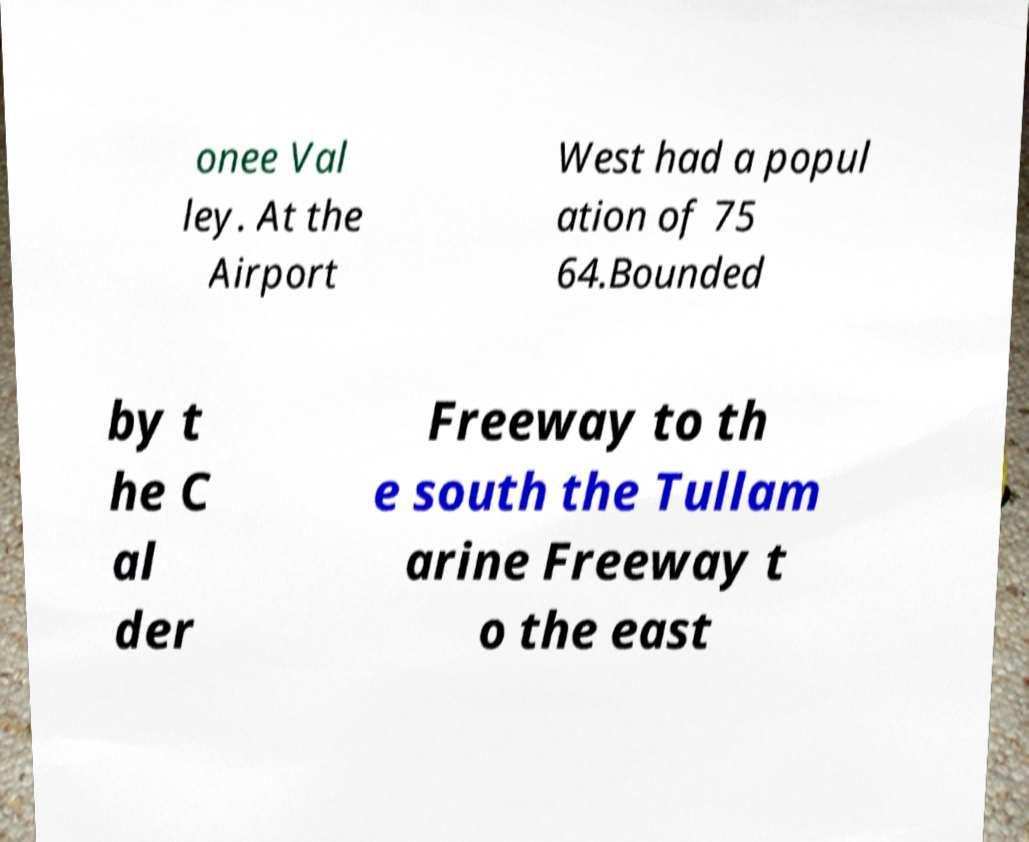For documentation purposes, I need the text within this image transcribed. Could you provide that? onee Val ley. At the Airport West had a popul ation of 75 64.Bounded by t he C al der Freeway to th e south the Tullam arine Freeway t o the east 